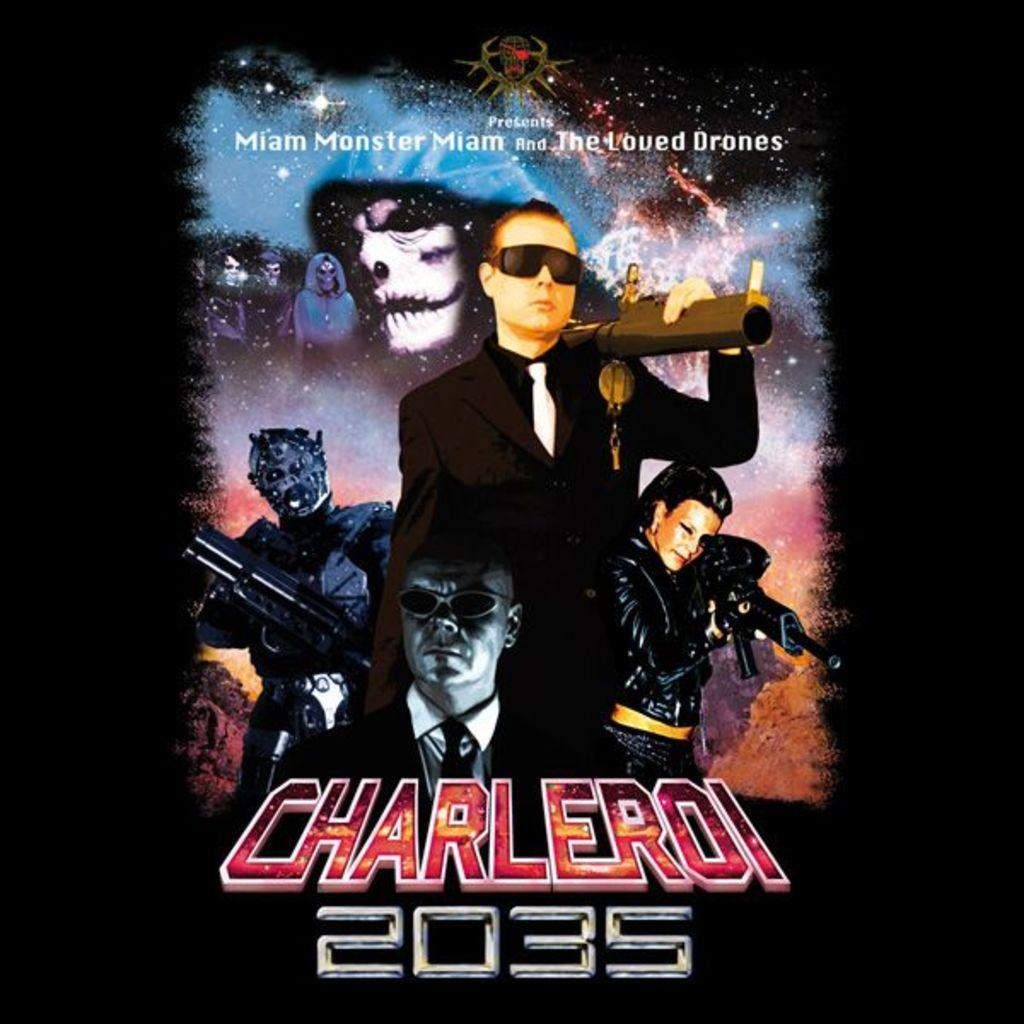Provide a one-sentence caption for the provided image. An ad has the title Charleroi 2035 on it below a picture of a man in glasses. 